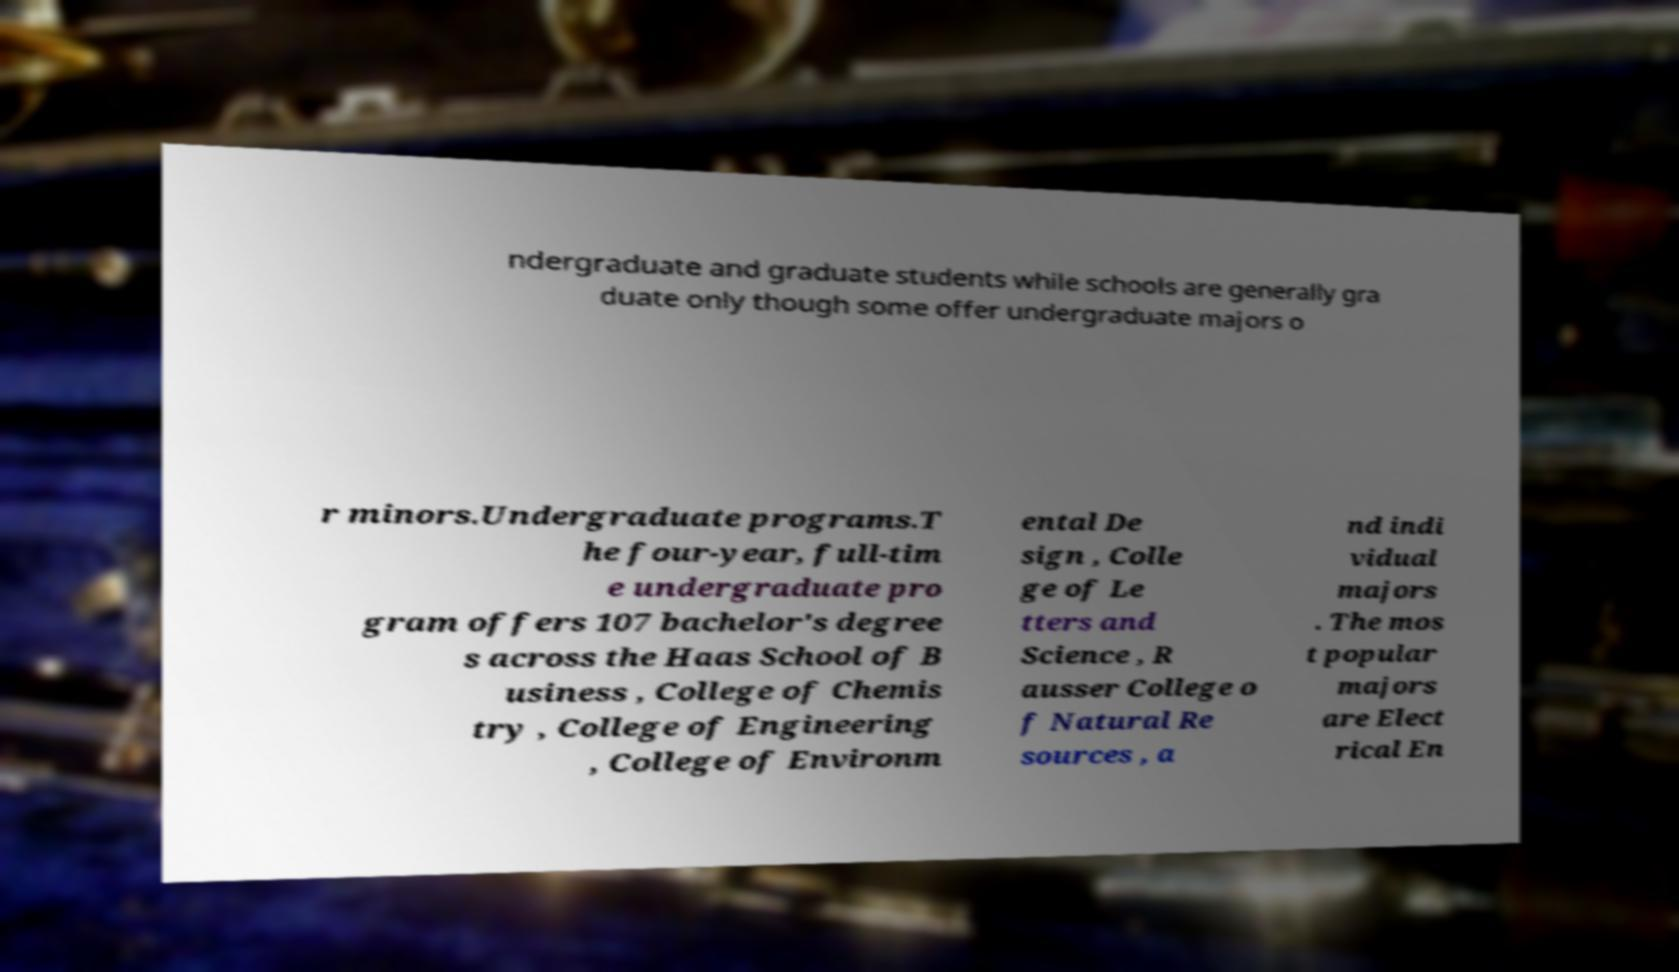For documentation purposes, I need the text within this image transcribed. Could you provide that? ndergraduate and graduate students while schools are generally gra duate only though some offer undergraduate majors o r minors.Undergraduate programs.T he four-year, full-tim e undergraduate pro gram offers 107 bachelor's degree s across the Haas School of B usiness , College of Chemis try , College of Engineering , College of Environm ental De sign , Colle ge of Le tters and Science , R ausser College o f Natural Re sources , a nd indi vidual majors . The mos t popular majors are Elect rical En 